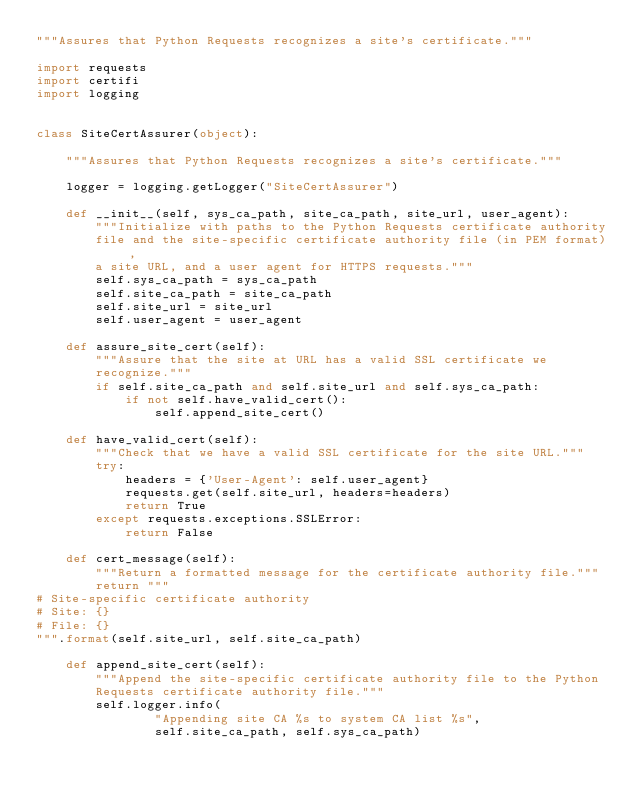<code> <loc_0><loc_0><loc_500><loc_500><_Python_>"""Assures that Python Requests recognizes a site's certificate."""

import requests
import certifi
import logging


class SiteCertAssurer(object):

    """Assures that Python Requests recognizes a site's certificate."""

    logger = logging.getLogger("SiteCertAssurer")

    def __init__(self, sys_ca_path, site_ca_path, site_url, user_agent):
        """Initialize with paths to the Python Requests certificate authority
        file and the site-specific certificate authority file (in PEM format),
        a site URL, and a user agent for HTTPS requests."""
        self.sys_ca_path = sys_ca_path
        self.site_ca_path = site_ca_path
        self.site_url = site_url
        self.user_agent = user_agent

    def assure_site_cert(self):
        """Assure that the site at URL has a valid SSL certificate we
        recognize."""
        if self.site_ca_path and self.site_url and self.sys_ca_path:
            if not self.have_valid_cert():
                self.append_site_cert()

    def have_valid_cert(self):
        """Check that we have a valid SSL certificate for the site URL."""
        try:
            headers = {'User-Agent': self.user_agent}
            requests.get(self.site_url, headers=headers)
            return True
        except requests.exceptions.SSLError:
            return False

    def cert_message(self):
        """Return a formatted message for the certificate authority file."""
        return """
# Site-specific certificate authority
# Site: {}
# File: {}
""".format(self.site_url, self.site_ca_path)

    def append_site_cert(self):
        """Append the site-specific certificate authority file to the Python
        Requests certificate authority file."""
        self.logger.info(
                "Appending site CA %s to system CA list %s",
                self.site_ca_path, self.sys_ca_path)</code> 